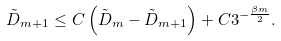Convert formula to latex. <formula><loc_0><loc_0><loc_500><loc_500>\tilde { D } _ { m + 1 } \leq C \left ( \tilde { D } _ { m } - \tilde { D } _ { m + 1 } \right ) + C 3 ^ { - \frac { \beta m } { 2 } } .</formula> 